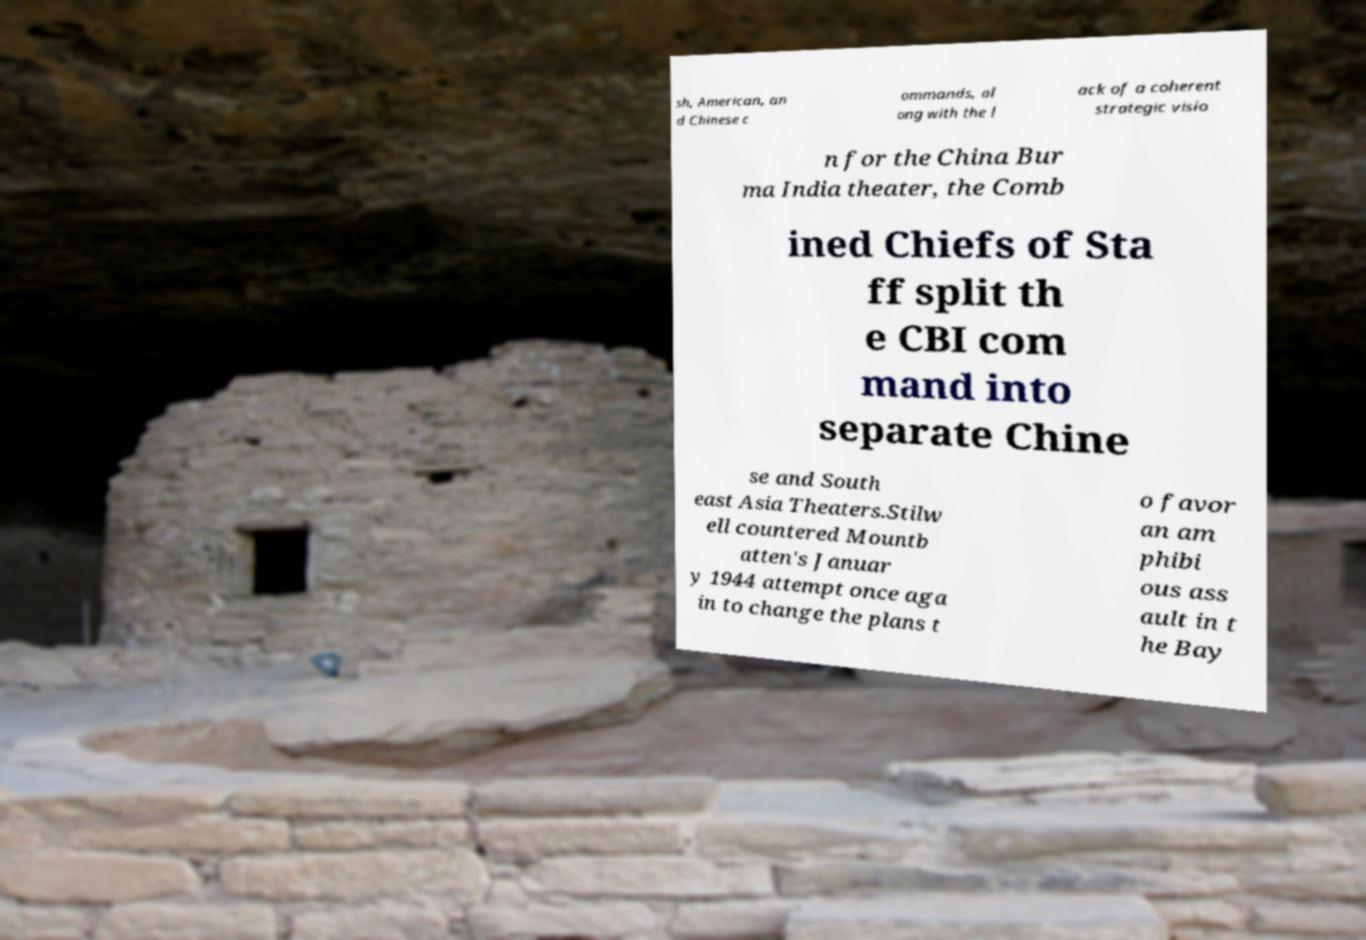Please read and relay the text visible in this image. What does it say? sh, American, an d Chinese c ommands, al ong with the l ack of a coherent strategic visio n for the China Bur ma India theater, the Comb ined Chiefs of Sta ff split th e CBI com mand into separate Chine se and South east Asia Theaters.Stilw ell countered Mountb atten's Januar y 1944 attempt once aga in to change the plans t o favor an am phibi ous ass ault in t he Bay 